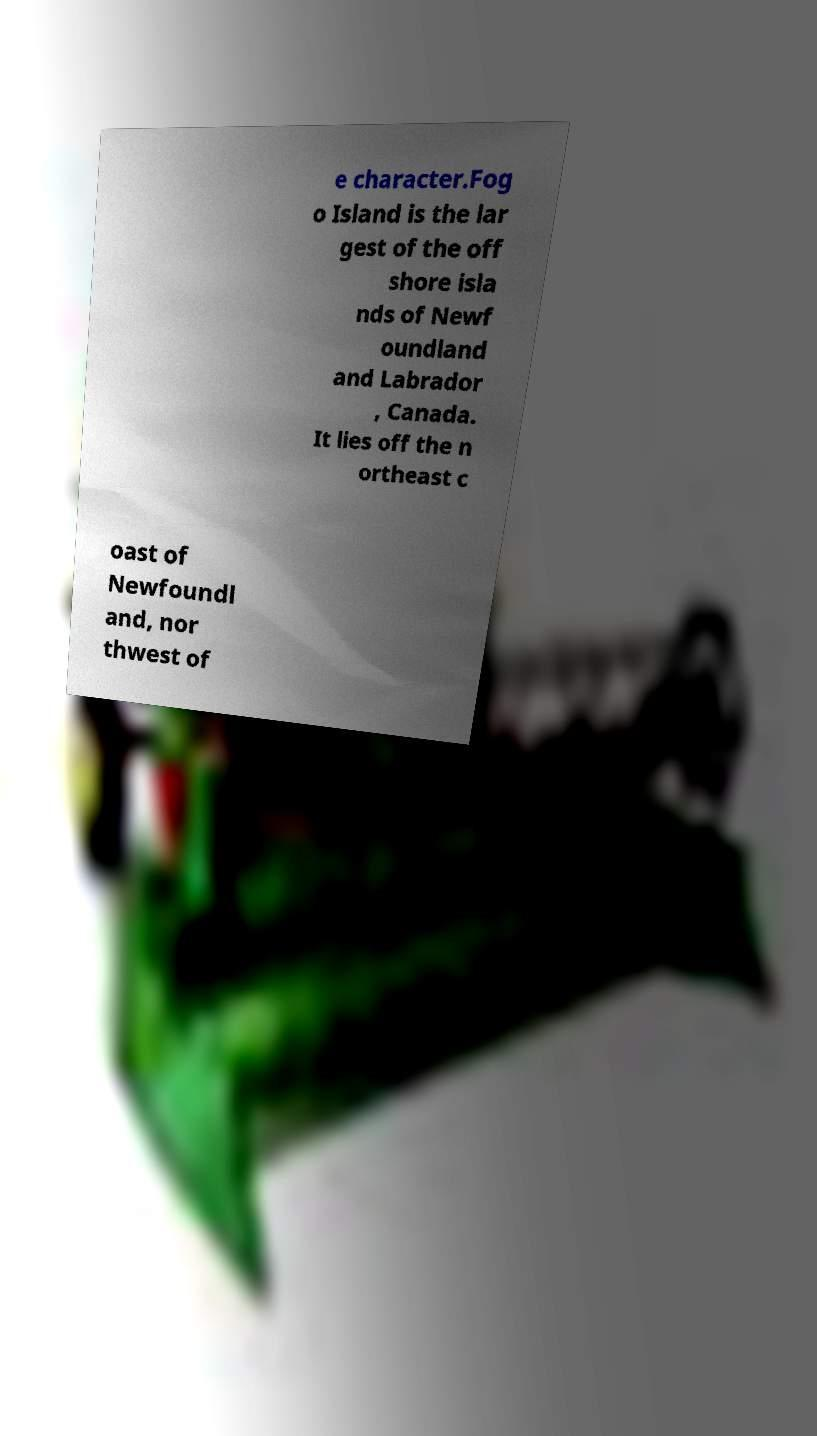Please read and relay the text visible in this image. What does it say? e character.Fog o Island is the lar gest of the off shore isla nds of Newf oundland and Labrador , Canada. It lies off the n ortheast c oast of Newfoundl and, nor thwest of 